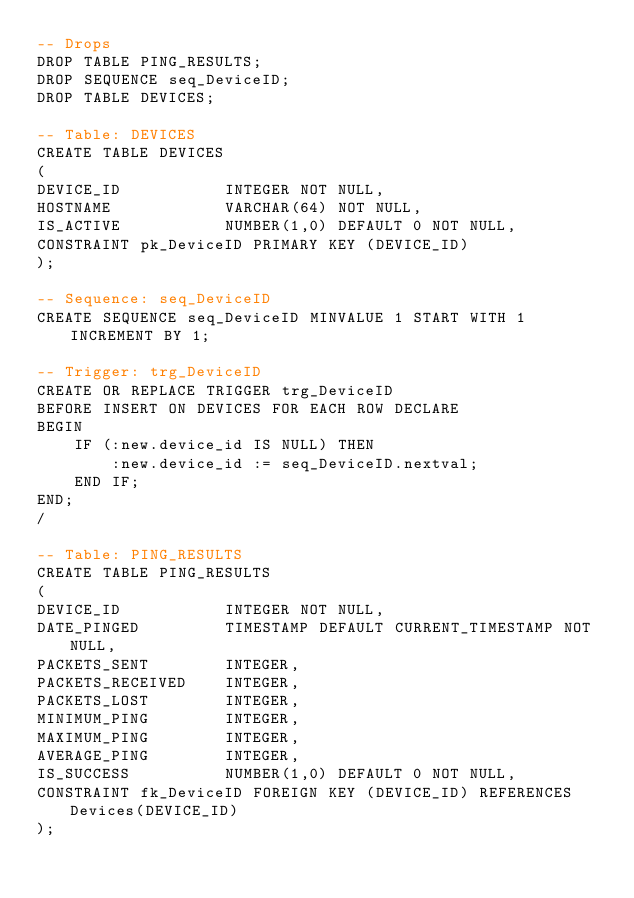<code> <loc_0><loc_0><loc_500><loc_500><_SQL_>-- Drops
DROP TABLE PING_RESULTS;
DROP SEQUENCE seq_DeviceID;
DROP TABLE DEVICES;

-- Table: DEVICES
CREATE TABLE DEVICES
(
DEVICE_ID			INTEGER NOT NULL,
HOSTNAME 			VARCHAR(64) NOT NULL,
IS_ACTIVE			NUMBER(1,0) DEFAULT 0 NOT NULL,
CONSTRAINT pk_DeviceID PRIMARY KEY (DEVICE_ID)
);

-- Sequence: seq_DeviceID
CREATE SEQUENCE seq_DeviceID MINVALUE 1 START WITH 1 INCREMENT BY 1;

-- Trigger: trg_DeviceID
CREATE OR REPLACE TRIGGER trg_DeviceID
BEFORE INSERT ON DEVICES FOR EACH ROW DECLARE
BEGIN
	IF (:new.device_id IS NULL) THEN
		:new.device_id := seq_DeviceID.nextval;
	END IF;
END;
/

-- Table: PING_RESULTS
CREATE TABLE PING_RESULTS
(
DEVICE_ID 			INTEGER NOT NULL,
DATE_PINGED			TIMESTAMP DEFAULT CURRENT_TIMESTAMP NOT NULL,
PACKETS_SENT		INTEGER,
PACKETS_RECEIVED	INTEGER,
PACKETS_LOST		INTEGER,
MINIMUM_PING		INTEGER,
MAXIMUM_PING		INTEGER,
AVERAGE_PING		INTEGER,
IS_SUCCESS			NUMBER(1,0) DEFAULT 0 NOT NULL,
CONSTRAINT fk_DeviceID FOREIGN KEY (DEVICE_ID) REFERENCES Devices(DEVICE_ID)
);
</code> 